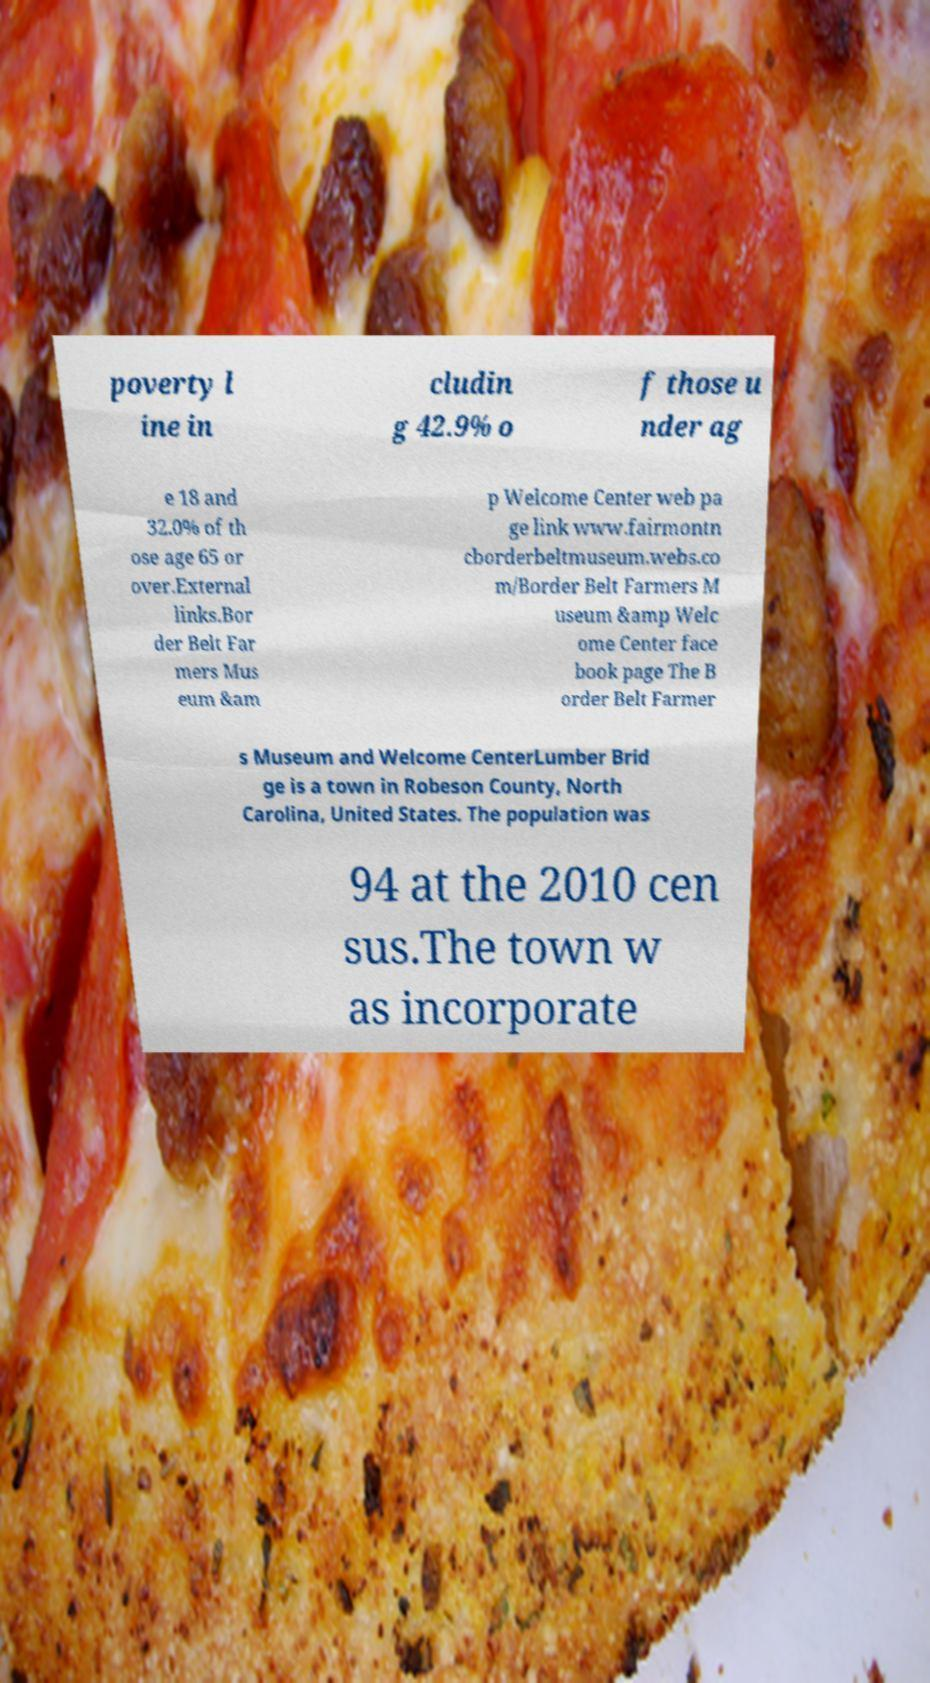What messages or text are displayed in this image? I need them in a readable, typed format. poverty l ine in cludin g 42.9% o f those u nder ag e 18 and 32.0% of th ose age 65 or over.External links.Bor der Belt Far mers Mus eum &am p Welcome Center web pa ge link www.fairmontn cborderbeltmuseum.webs.co m/Border Belt Farmers M useum &amp Welc ome Center face book page The B order Belt Farmer s Museum and Welcome CenterLumber Brid ge is a town in Robeson County, North Carolina, United States. The population was 94 at the 2010 cen sus.The town w as incorporate 